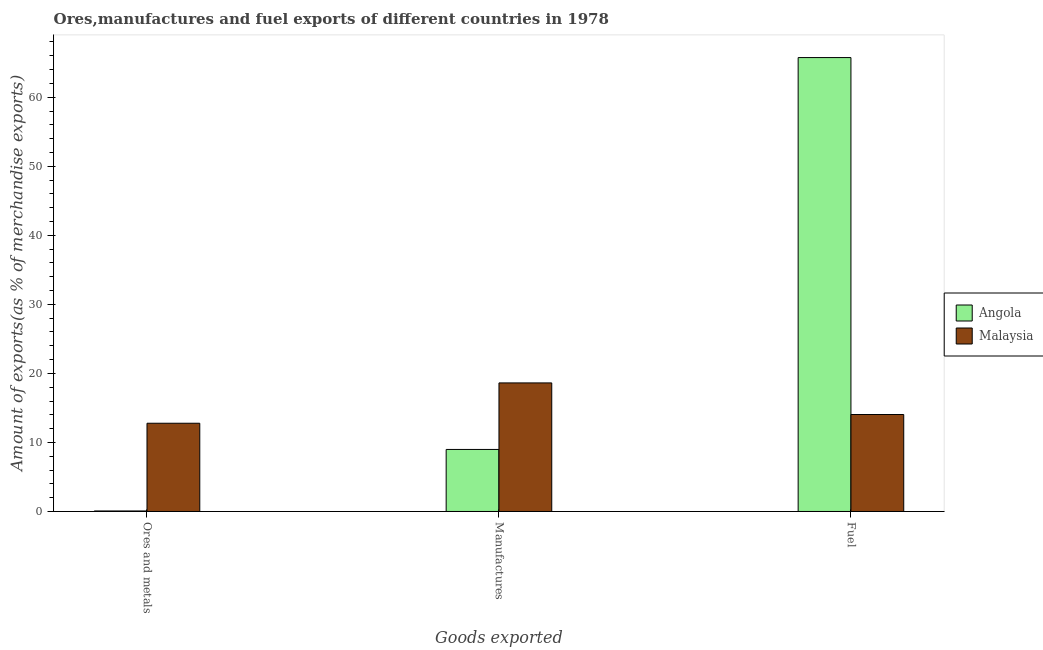How many different coloured bars are there?
Give a very brief answer. 2. Are the number of bars per tick equal to the number of legend labels?
Your response must be concise. Yes. Are the number of bars on each tick of the X-axis equal?
Offer a terse response. Yes. How many bars are there on the 3rd tick from the right?
Provide a succinct answer. 2. What is the label of the 1st group of bars from the left?
Keep it short and to the point. Ores and metals. What is the percentage of fuel exports in Angola?
Your answer should be very brief. 65.74. Across all countries, what is the maximum percentage of manufactures exports?
Your answer should be compact. 18.62. Across all countries, what is the minimum percentage of manufactures exports?
Your answer should be very brief. 8.98. In which country was the percentage of manufactures exports maximum?
Give a very brief answer. Malaysia. In which country was the percentage of fuel exports minimum?
Make the answer very short. Malaysia. What is the total percentage of ores and metals exports in the graph?
Ensure brevity in your answer.  12.85. What is the difference between the percentage of fuel exports in Angola and that in Malaysia?
Your response must be concise. 51.7. What is the difference between the percentage of fuel exports in Angola and the percentage of manufactures exports in Malaysia?
Your answer should be very brief. 47.12. What is the average percentage of fuel exports per country?
Offer a terse response. 39.89. What is the difference between the percentage of ores and metals exports and percentage of manufactures exports in Malaysia?
Give a very brief answer. -5.84. What is the ratio of the percentage of fuel exports in Angola to that in Malaysia?
Offer a terse response. 4.68. Is the difference between the percentage of ores and metals exports in Malaysia and Angola greater than the difference between the percentage of manufactures exports in Malaysia and Angola?
Offer a very short reply. Yes. What is the difference between the highest and the second highest percentage of fuel exports?
Keep it short and to the point. 51.7. What is the difference between the highest and the lowest percentage of fuel exports?
Your response must be concise. 51.7. In how many countries, is the percentage of fuel exports greater than the average percentage of fuel exports taken over all countries?
Keep it short and to the point. 1. Is the sum of the percentage of ores and metals exports in Malaysia and Angola greater than the maximum percentage of fuel exports across all countries?
Give a very brief answer. No. What does the 1st bar from the left in Fuel represents?
Give a very brief answer. Angola. What does the 2nd bar from the right in Fuel represents?
Provide a succinct answer. Angola. Is it the case that in every country, the sum of the percentage of ores and metals exports and percentage of manufactures exports is greater than the percentage of fuel exports?
Offer a terse response. No. How many countries are there in the graph?
Provide a short and direct response. 2. What is the difference between two consecutive major ticks on the Y-axis?
Provide a short and direct response. 10. Are the values on the major ticks of Y-axis written in scientific E-notation?
Provide a succinct answer. No. Does the graph contain any zero values?
Provide a short and direct response. No. How many legend labels are there?
Your answer should be compact. 2. What is the title of the graph?
Your response must be concise. Ores,manufactures and fuel exports of different countries in 1978. Does "South Sudan" appear as one of the legend labels in the graph?
Your response must be concise. No. What is the label or title of the X-axis?
Keep it short and to the point. Goods exported. What is the label or title of the Y-axis?
Provide a short and direct response. Amount of exports(as % of merchandise exports). What is the Amount of exports(as % of merchandise exports) in Angola in Ores and metals?
Provide a succinct answer. 0.07. What is the Amount of exports(as % of merchandise exports) in Malaysia in Ores and metals?
Your answer should be compact. 12.78. What is the Amount of exports(as % of merchandise exports) of Angola in Manufactures?
Your answer should be compact. 8.98. What is the Amount of exports(as % of merchandise exports) of Malaysia in Manufactures?
Give a very brief answer. 18.62. What is the Amount of exports(as % of merchandise exports) in Angola in Fuel?
Your answer should be compact. 65.74. What is the Amount of exports(as % of merchandise exports) in Malaysia in Fuel?
Provide a succinct answer. 14.04. Across all Goods exported, what is the maximum Amount of exports(as % of merchandise exports) in Angola?
Offer a very short reply. 65.74. Across all Goods exported, what is the maximum Amount of exports(as % of merchandise exports) in Malaysia?
Your response must be concise. 18.62. Across all Goods exported, what is the minimum Amount of exports(as % of merchandise exports) in Angola?
Provide a succinct answer. 0.07. Across all Goods exported, what is the minimum Amount of exports(as % of merchandise exports) in Malaysia?
Offer a very short reply. 12.78. What is the total Amount of exports(as % of merchandise exports) in Angola in the graph?
Keep it short and to the point. 74.8. What is the total Amount of exports(as % of merchandise exports) of Malaysia in the graph?
Make the answer very short. 45.45. What is the difference between the Amount of exports(as % of merchandise exports) in Angola in Ores and metals and that in Manufactures?
Ensure brevity in your answer.  -8.91. What is the difference between the Amount of exports(as % of merchandise exports) in Malaysia in Ores and metals and that in Manufactures?
Provide a short and direct response. -5.84. What is the difference between the Amount of exports(as % of merchandise exports) of Angola in Ores and metals and that in Fuel?
Your answer should be compact. -65.66. What is the difference between the Amount of exports(as % of merchandise exports) in Malaysia in Ores and metals and that in Fuel?
Provide a short and direct response. -1.26. What is the difference between the Amount of exports(as % of merchandise exports) of Angola in Manufactures and that in Fuel?
Give a very brief answer. -56.76. What is the difference between the Amount of exports(as % of merchandise exports) of Malaysia in Manufactures and that in Fuel?
Provide a succinct answer. 4.58. What is the difference between the Amount of exports(as % of merchandise exports) of Angola in Ores and metals and the Amount of exports(as % of merchandise exports) of Malaysia in Manufactures?
Give a very brief answer. -18.55. What is the difference between the Amount of exports(as % of merchandise exports) in Angola in Ores and metals and the Amount of exports(as % of merchandise exports) in Malaysia in Fuel?
Provide a short and direct response. -13.97. What is the difference between the Amount of exports(as % of merchandise exports) in Angola in Manufactures and the Amount of exports(as % of merchandise exports) in Malaysia in Fuel?
Your answer should be compact. -5.06. What is the average Amount of exports(as % of merchandise exports) of Angola per Goods exported?
Provide a succinct answer. 24.93. What is the average Amount of exports(as % of merchandise exports) of Malaysia per Goods exported?
Your answer should be very brief. 15.15. What is the difference between the Amount of exports(as % of merchandise exports) in Angola and Amount of exports(as % of merchandise exports) in Malaysia in Ores and metals?
Your answer should be very brief. -12.71. What is the difference between the Amount of exports(as % of merchandise exports) of Angola and Amount of exports(as % of merchandise exports) of Malaysia in Manufactures?
Offer a terse response. -9.64. What is the difference between the Amount of exports(as % of merchandise exports) of Angola and Amount of exports(as % of merchandise exports) of Malaysia in Fuel?
Provide a short and direct response. 51.7. What is the ratio of the Amount of exports(as % of merchandise exports) of Angola in Ores and metals to that in Manufactures?
Keep it short and to the point. 0.01. What is the ratio of the Amount of exports(as % of merchandise exports) in Malaysia in Ores and metals to that in Manufactures?
Ensure brevity in your answer.  0.69. What is the ratio of the Amount of exports(as % of merchandise exports) in Angola in Ores and metals to that in Fuel?
Keep it short and to the point. 0. What is the ratio of the Amount of exports(as % of merchandise exports) of Malaysia in Ores and metals to that in Fuel?
Offer a very short reply. 0.91. What is the ratio of the Amount of exports(as % of merchandise exports) of Angola in Manufactures to that in Fuel?
Give a very brief answer. 0.14. What is the ratio of the Amount of exports(as % of merchandise exports) in Malaysia in Manufactures to that in Fuel?
Provide a short and direct response. 1.33. What is the difference between the highest and the second highest Amount of exports(as % of merchandise exports) of Angola?
Provide a succinct answer. 56.76. What is the difference between the highest and the second highest Amount of exports(as % of merchandise exports) in Malaysia?
Your response must be concise. 4.58. What is the difference between the highest and the lowest Amount of exports(as % of merchandise exports) in Angola?
Give a very brief answer. 65.66. What is the difference between the highest and the lowest Amount of exports(as % of merchandise exports) of Malaysia?
Provide a short and direct response. 5.84. 